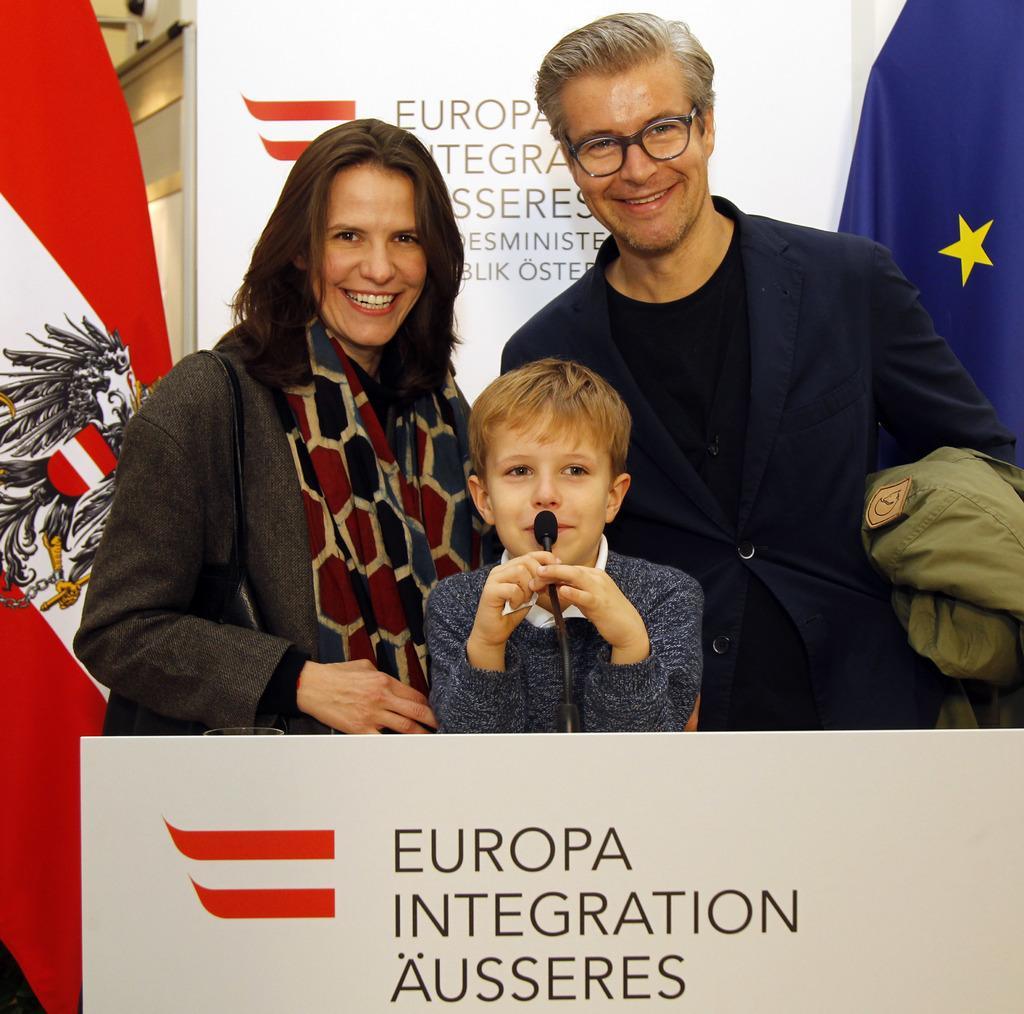Please provide a concise description of this image. As we can see in the image there is a white color banner, red and white color flag. Three people standing over here and this boy is holding mic. 